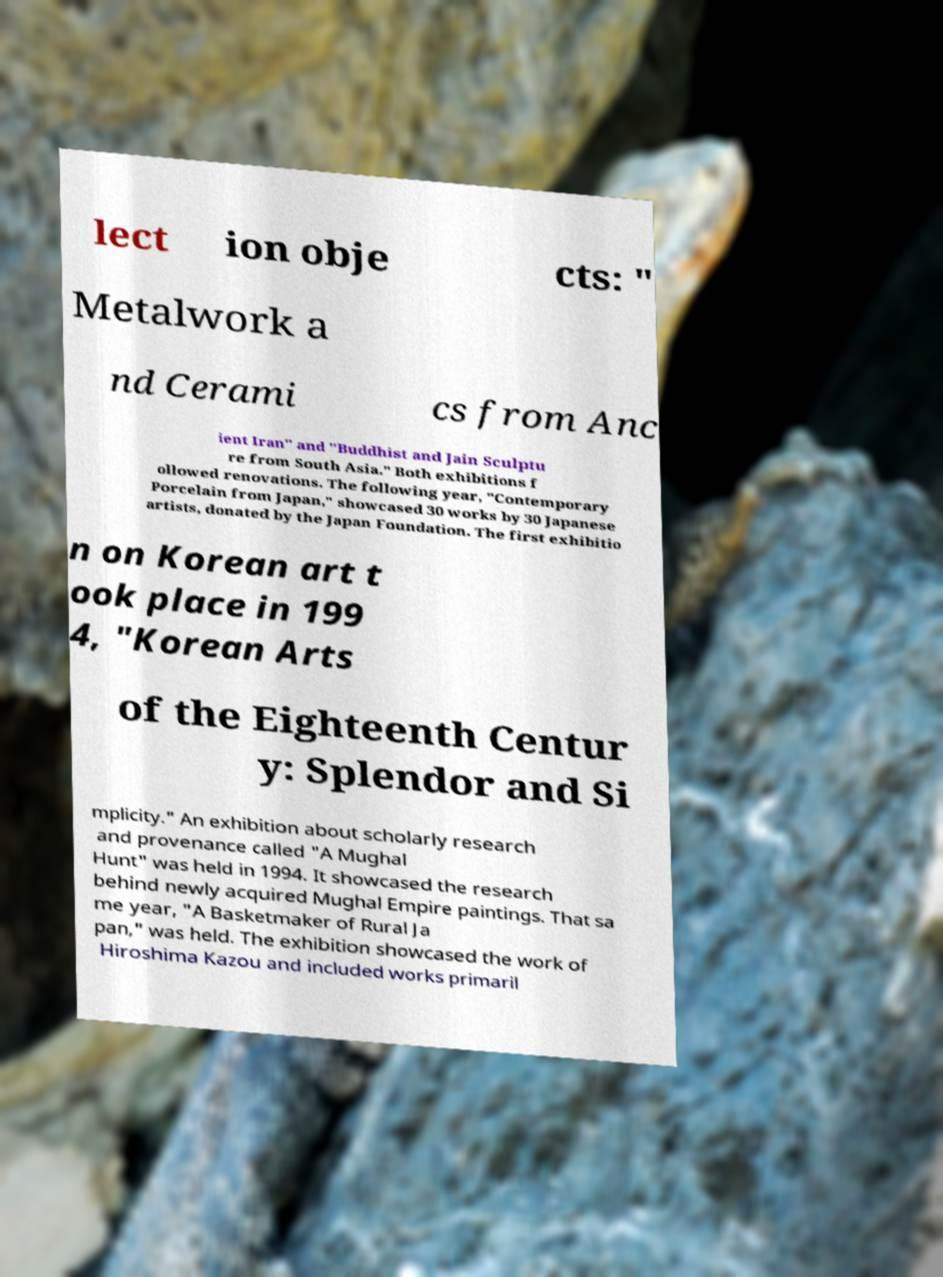Please identify and transcribe the text found in this image. lect ion obje cts: " Metalwork a nd Cerami cs from Anc ient Iran" and "Buddhist and Jain Sculptu re from South Asia." Both exhibitions f ollowed renovations. The following year, "Contemporary Porcelain from Japan," showcased 30 works by 30 Japanese artists, donated by the Japan Foundation. The first exhibitio n on Korean art t ook place in 199 4, "Korean Arts of the Eighteenth Centur y: Splendor and Si mplicity." An exhibition about scholarly research and provenance called "A Mughal Hunt" was held in 1994. It showcased the research behind newly acquired Mughal Empire paintings. That sa me year, "A Basketmaker of Rural Ja pan," was held. The exhibition showcased the work of Hiroshima Kazou and included works primaril 